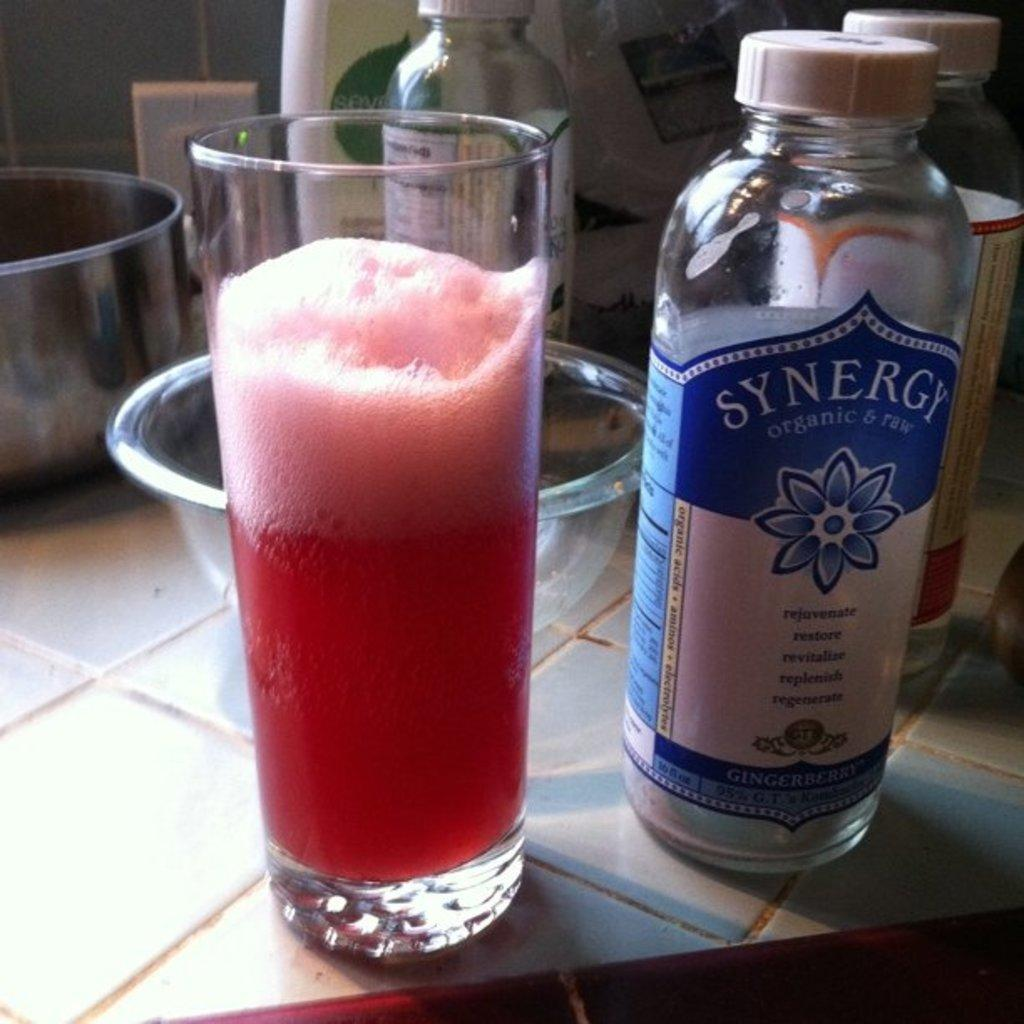<image>
Present a compact description of the photo's key features. A bottle of Synergy is next to a glass half full of red liquid. 